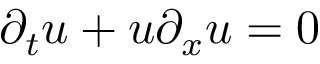Convert formula to latex. <formula><loc_0><loc_0><loc_500><loc_500>\partial _ { t } u + u \partial _ { x } u = 0</formula> 